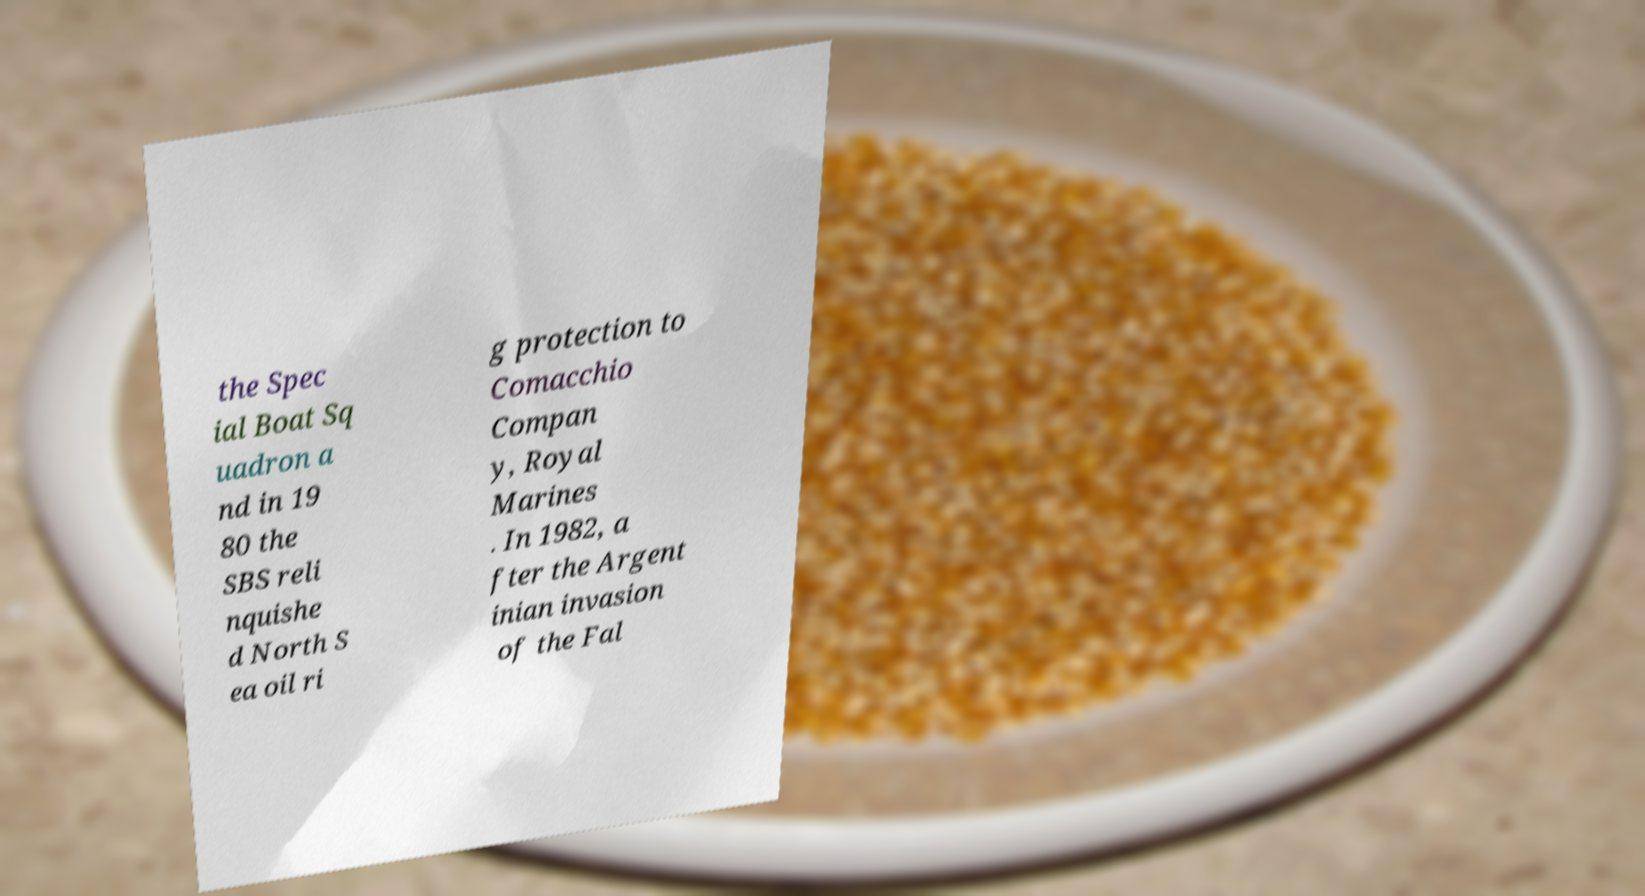Can you accurately transcribe the text from the provided image for me? the Spec ial Boat Sq uadron a nd in 19 80 the SBS reli nquishe d North S ea oil ri g protection to Comacchio Compan y, Royal Marines . In 1982, a fter the Argent inian invasion of the Fal 